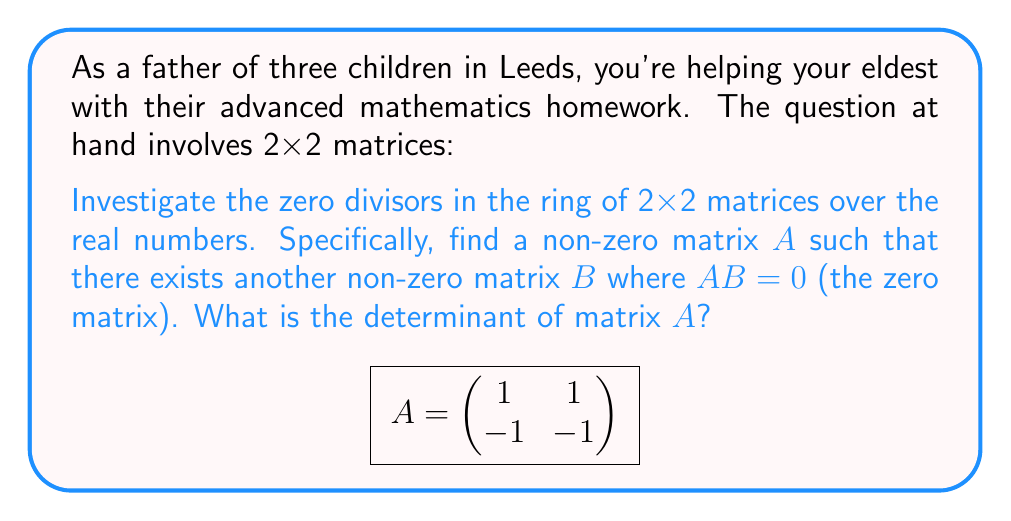Could you help me with this problem? Let's approach this step-by-step:

1) First, we need to understand what zero divisors are in a ring. A zero divisor is a non-zero element $a$ in a ring for which there exists a non-zero element $b$ such that $ab = 0$ or $ba = 0$.

2) In the ring of 2x2 matrices, we're looking for a non-zero matrix $A$ such that there exists another non-zero matrix $B$ where $AB = 0$.

3) The given matrix $A$ is:

   $$A = \begin{pmatrix} 1 & 1 \\ -1 & -1 \end{pmatrix}$$

4) To show that $A$ is a zero divisor, we need to find a non-zero matrix $B$ such that $AB = 0$. Let's try:

   $$B = \begin{pmatrix} 1 \\ -1 \end{pmatrix}$$

5) Now, let's multiply $A$ and $B$:

   $$AB = \begin{pmatrix} 1 & 1 \\ -1 & -1 \end{pmatrix} \begin{pmatrix} 1 \\ -1 \end{pmatrix} = \begin{pmatrix} 1(1) + 1(-1) \\ -1(1) + -1(-1) \end{pmatrix} = \begin{pmatrix} 0 \\ 0 \end{pmatrix}$$

6) This proves that $A$ is indeed a zero divisor in the ring of 2x2 matrices.

7) To find the determinant of $A$, we use the formula for a 2x2 matrix:

   $\det(A) = ad - bc$ where $A = \begin{pmatrix} a & b \\ c & d \end{pmatrix}$

8) For our matrix $A$:

   $\det(A) = (1)(-1) - (1)(-1) = -1 - (-1) = 0$

Therefore, the determinant of matrix $A$ is 0.
Answer: 0 